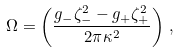Convert formula to latex. <formula><loc_0><loc_0><loc_500><loc_500>\Omega = \left ( \frac { g _ { - } \zeta _ { - } ^ { 2 } - g _ { + } \zeta _ { + } ^ { 2 } } { 2 \pi \kappa ^ { 2 } } \right ) \, ,</formula> 